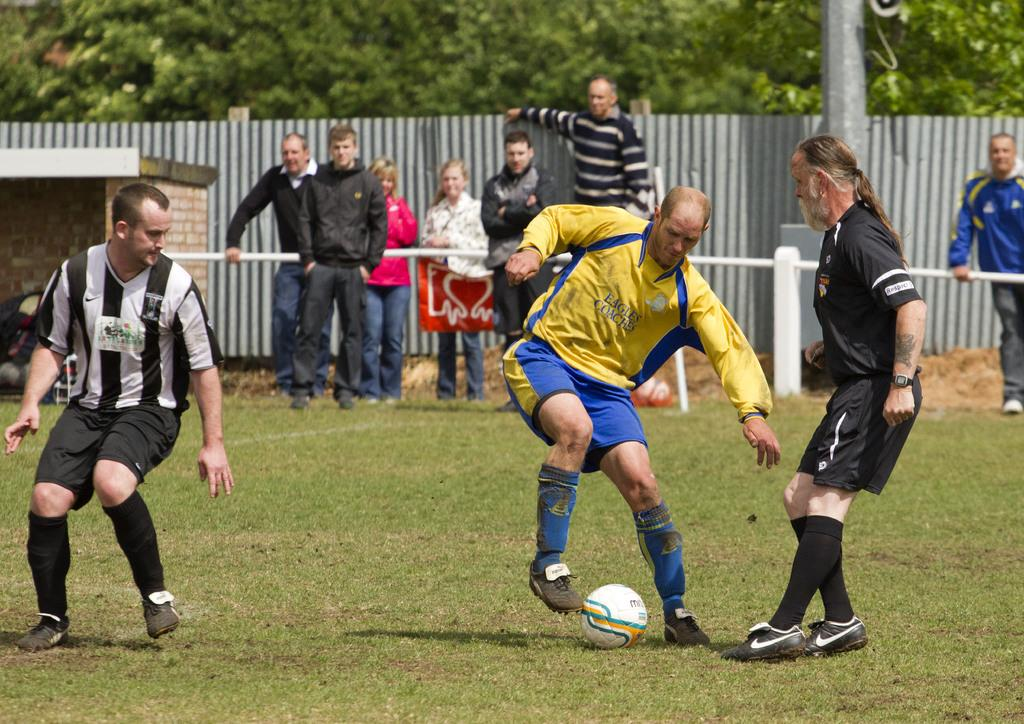What activity are the people in the image engaged in? The people in the image are playing football. Can you describe the people in the foreground of the image? There are more people standing in the background of the image. What can be seen behind the people in the image? There are trees visible at the back of the people. What type of lip balm is being used by the players in the image? There is no lip balm present in the image, as it features people playing football. 